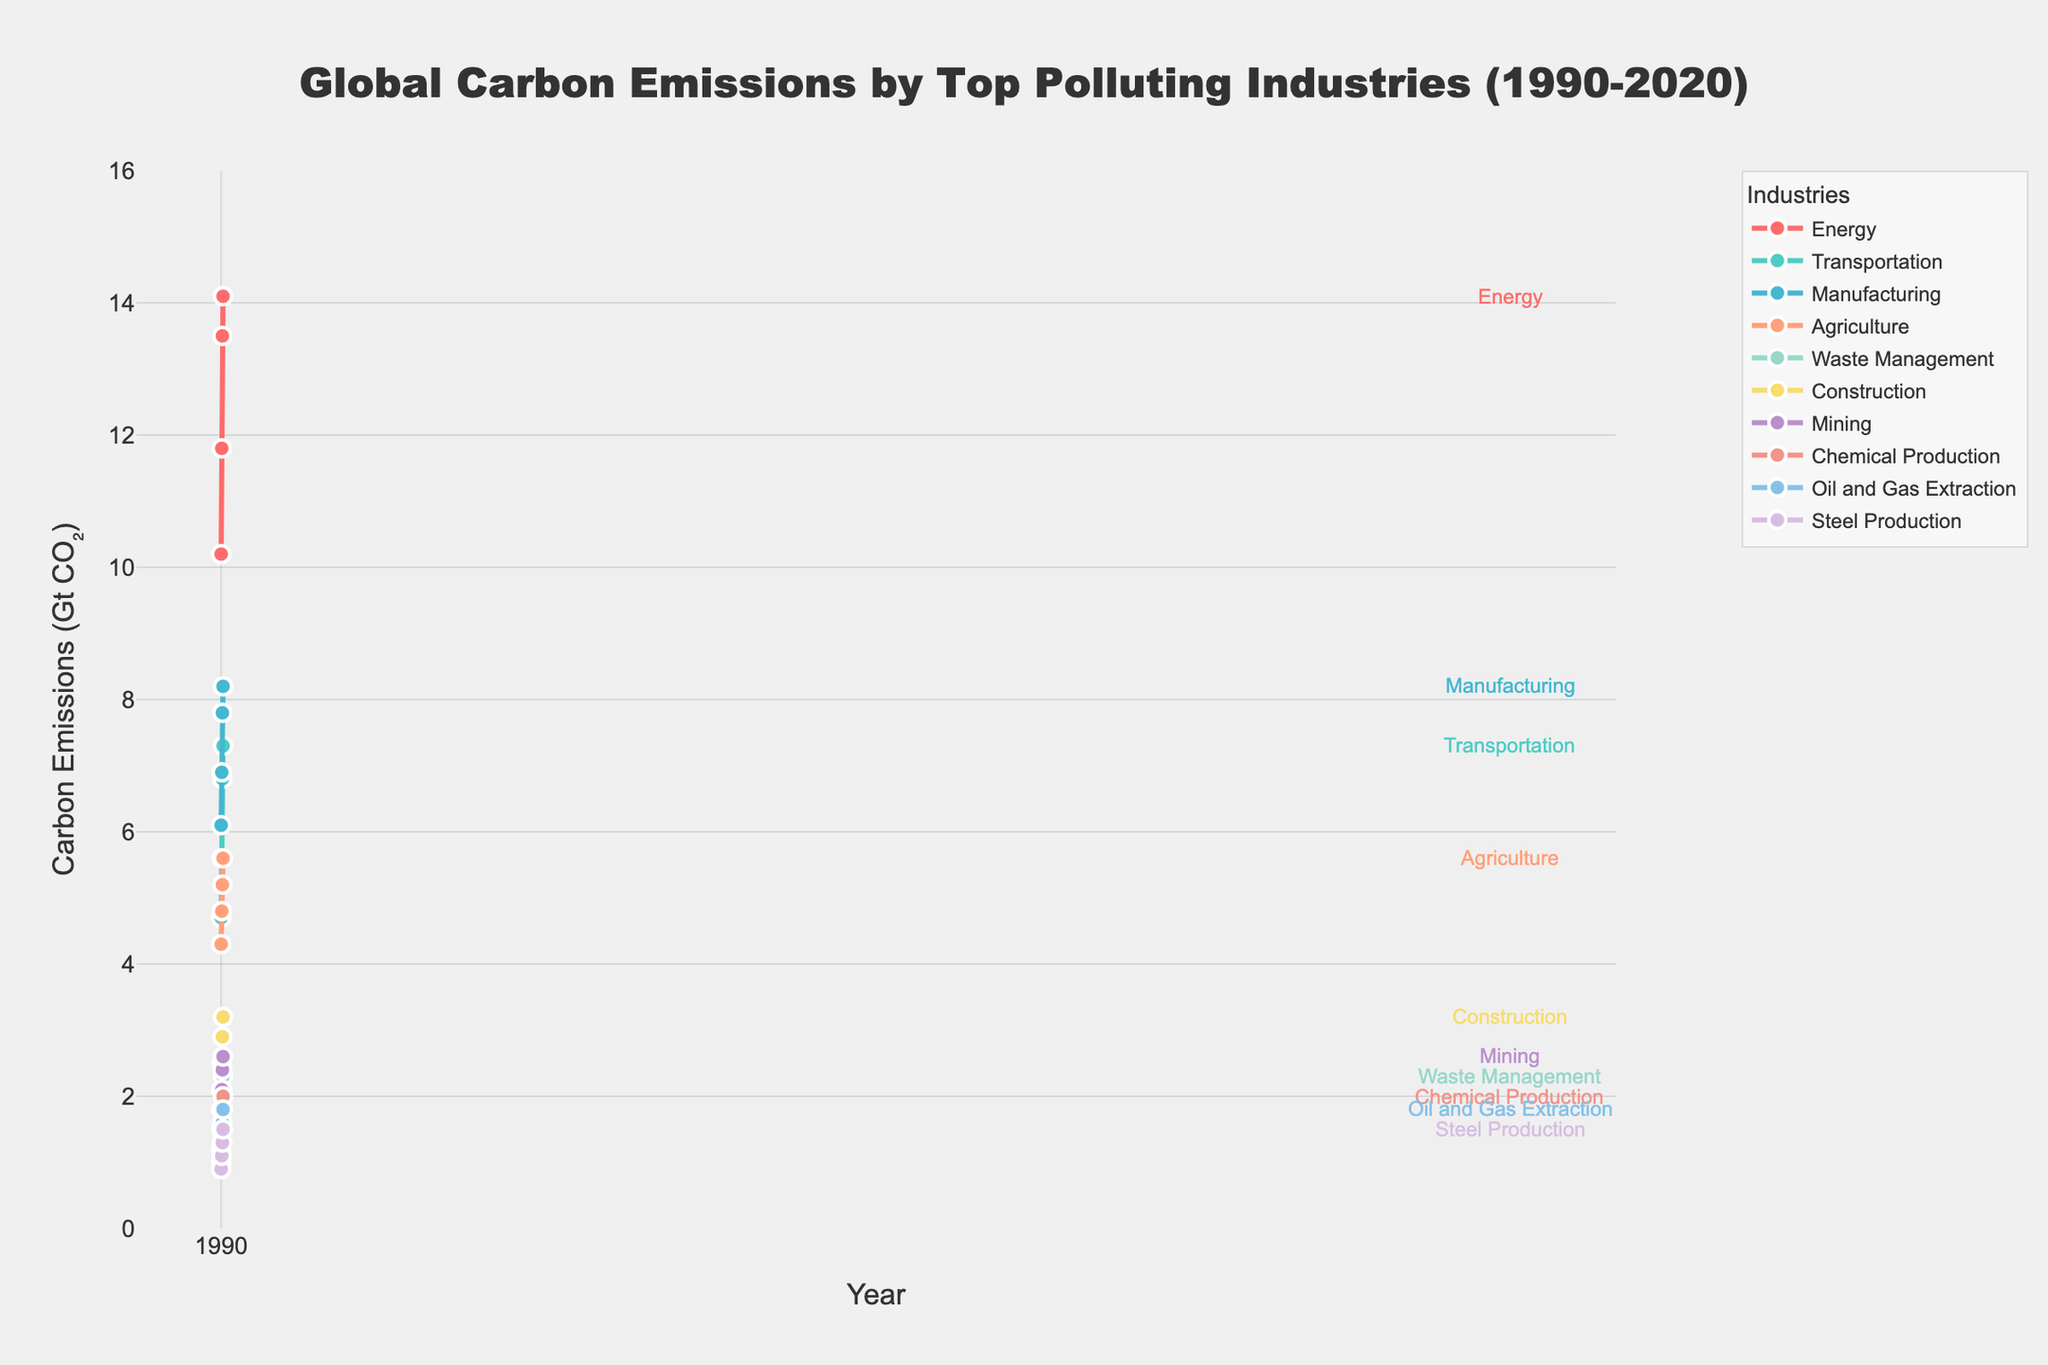What industry had the highest carbon emissions in 2020? The highest point on the vertical axis for 2020 corresponds to the Energy sector.
Answer: Energy Which industry saw the largest increase in carbon emissions from 1990 to 2020? Calculate the difference for each industry from 1990 to 2020. Energy grew from 10.2 to 14.1, which is an increase of 3.9 Gt CO₂, the largest among all industries.
Answer: Energy What is the total carbon emission from Manufacturing and Transportation in 2000? Sum the values for Manufacturing (6.9) and Transportation (5.6) in 2000. 6.9 + 5.6 = 12.5 Gt CO₂
Answer: 12.5 Gt CO₂ Which industry had the smallest carbon emissions in 1990? The lowest point on the vertical axis for 1990 corresponds to Steel Production.
Answer: Steel Production By how much did carbon emissions from Agriculture increase from 1990 to 2020? Subtract the value for 1990 (4.3) from the value for 2020 (5.6). 5.6 - 4.3 = 1.3 Gt CO₂
Answer: 1.3 Gt CO₂ Comparing 2010, which industry had higher emissions: Construction or Waste Management? Compare the values for Construction (2.9) and Waste Management (2.1) in 2010. Construction had higher emissions.
Answer: Construction Which two industries had the closest carbon emission values in 2020? Compare the 2020 values and find the two industries with the smallest difference. Oil and Gas Extraction (1.8) and Steel Production (1.5) differ by only 0.3 Gt CO₂.
Answer: Oil and Gas Extraction and Steel Production What is the average carbon emission for Mining across all years? Sum the emission values for Mining (1.8, 2.1, 2.4, 2.6) and divide by the number of years (4). (1.8 + 2.1 + 2.4 + 2.6) / 4 = 2.225 Gt CO₂
Answer: 2.225 Gt CO₂ How much more carbon did the Energy industry emit compared to Transportation in 2020? Subtract the 2020 value for Transportation (7.3) from the value for Energy (14.1). 14.1 - 7.3 = 6.8 Gt CO₂
Answer: 6.8 Gt CO₂ What is the difference between the carbon emissions by Waste Management in 2000 and 2020? Subtract the 2000 value (1.8) from the 2020 value (2.3). 2.3 - 1.8 = 0.5 Gt CO₂
Answer: 0.5 Gt CO₂ 